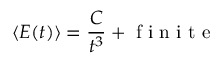<formula> <loc_0><loc_0><loc_500><loc_500>\langle E ( t ) \rangle = { \frac { C } { t ^ { 3 } } } + { f i n i t e }</formula> 